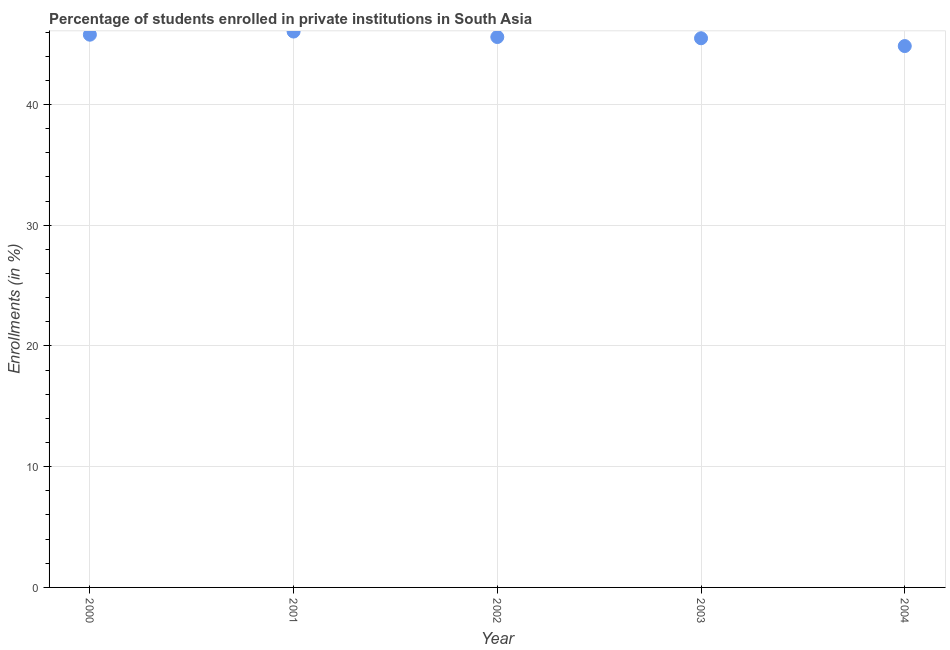What is the enrollments in private institutions in 2002?
Make the answer very short. 45.59. Across all years, what is the maximum enrollments in private institutions?
Your response must be concise. 46.04. Across all years, what is the minimum enrollments in private institutions?
Provide a short and direct response. 44.84. In which year was the enrollments in private institutions maximum?
Your answer should be compact. 2001. What is the sum of the enrollments in private institutions?
Your answer should be very brief. 227.73. What is the difference between the enrollments in private institutions in 2002 and 2004?
Keep it short and to the point. 0.75. What is the average enrollments in private institutions per year?
Your answer should be very brief. 45.55. What is the median enrollments in private institutions?
Offer a terse response. 45.59. In how many years, is the enrollments in private institutions greater than 12 %?
Your answer should be compact. 5. Do a majority of the years between 2004 and 2003 (inclusive) have enrollments in private institutions greater than 30 %?
Provide a succinct answer. No. What is the ratio of the enrollments in private institutions in 2001 to that in 2003?
Provide a succinct answer. 1.01. What is the difference between the highest and the second highest enrollments in private institutions?
Provide a short and direct response. 0.26. Is the sum of the enrollments in private institutions in 2000 and 2003 greater than the maximum enrollments in private institutions across all years?
Provide a succinct answer. Yes. What is the difference between the highest and the lowest enrollments in private institutions?
Offer a terse response. 1.2. In how many years, is the enrollments in private institutions greater than the average enrollments in private institutions taken over all years?
Provide a short and direct response. 3. What is the difference between two consecutive major ticks on the Y-axis?
Provide a short and direct response. 10. Are the values on the major ticks of Y-axis written in scientific E-notation?
Make the answer very short. No. Does the graph contain any zero values?
Provide a short and direct response. No. What is the title of the graph?
Ensure brevity in your answer.  Percentage of students enrolled in private institutions in South Asia. What is the label or title of the X-axis?
Make the answer very short. Year. What is the label or title of the Y-axis?
Offer a terse response. Enrollments (in %). What is the Enrollments (in %) in 2000?
Give a very brief answer. 45.78. What is the Enrollments (in %) in 2001?
Provide a succinct answer. 46.04. What is the Enrollments (in %) in 2002?
Provide a short and direct response. 45.59. What is the Enrollments (in %) in 2003?
Offer a very short reply. 45.48. What is the Enrollments (in %) in 2004?
Provide a short and direct response. 44.84. What is the difference between the Enrollments (in %) in 2000 and 2001?
Make the answer very short. -0.26. What is the difference between the Enrollments (in %) in 2000 and 2002?
Offer a terse response. 0.19. What is the difference between the Enrollments (in %) in 2000 and 2003?
Keep it short and to the point. 0.29. What is the difference between the Enrollments (in %) in 2000 and 2004?
Your answer should be very brief. 0.94. What is the difference between the Enrollments (in %) in 2001 and 2002?
Offer a terse response. 0.45. What is the difference between the Enrollments (in %) in 2001 and 2003?
Keep it short and to the point. 0.55. What is the difference between the Enrollments (in %) in 2001 and 2004?
Provide a succinct answer. 1.2. What is the difference between the Enrollments (in %) in 2002 and 2003?
Give a very brief answer. 0.1. What is the difference between the Enrollments (in %) in 2002 and 2004?
Ensure brevity in your answer.  0.75. What is the difference between the Enrollments (in %) in 2003 and 2004?
Make the answer very short. 0.65. What is the ratio of the Enrollments (in %) in 2000 to that in 2001?
Offer a terse response. 0.99. 